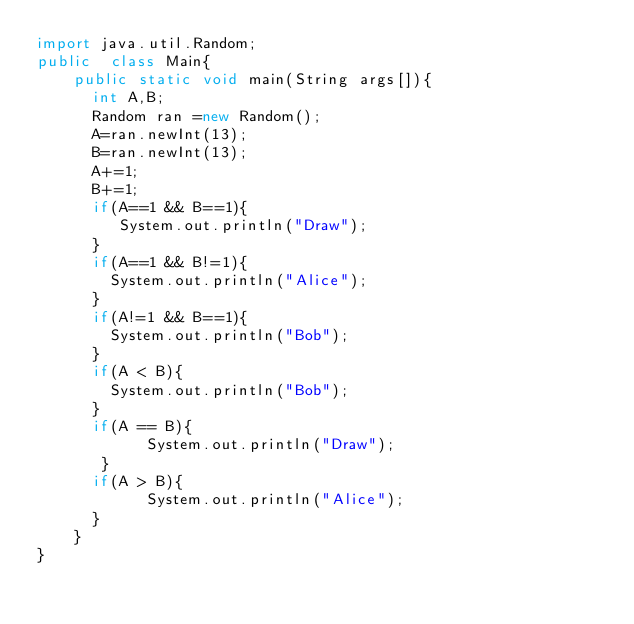<code> <loc_0><loc_0><loc_500><loc_500><_Java_>import java.util.Random;
public  class Main{
  	public static void main(String args[]){
      int A,B;
      Random ran =new Random();
      A=ran.newInt(13);
      B=ran.newInt(13);
      A+=1;
      B+=1;
      if(A==1 && B==1){
         System.out.println("Draw");
      }
      if(A==1 && B!=1){
      	System.out.println("Alice");
      }
      if(A!=1 && B==1){
        System.out.println("Bob");
      }
      if(A < B){
        System.out.println("Bob");
      }
      if(A == B){
        	System.out.println("Draw");
       }
      if(A > B){
        	System.out.println("Alice");
      }
    }
}
</code> 